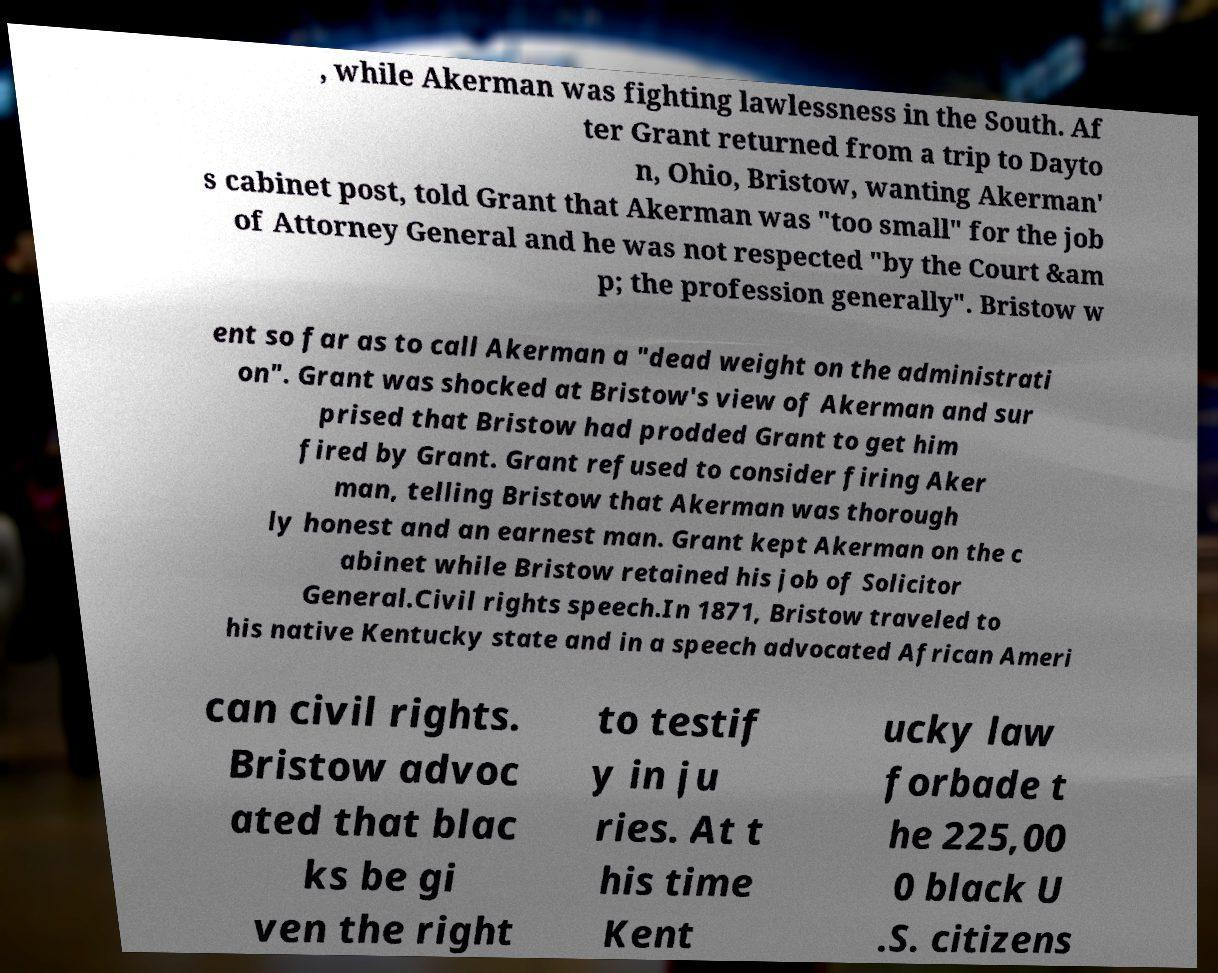There's text embedded in this image that I need extracted. Can you transcribe it verbatim? , while Akerman was fighting lawlessness in the South. Af ter Grant returned from a trip to Dayto n, Ohio, Bristow, wanting Akerman' s cabinet post, told Grant that Akerman was "too small" for the job of Attorney General and he was not respected "by the Court &am p; the profession generally". Bristow w ent so far as to call Akerman a "dead weight on the administrati on". Grant was shocked at Bristow's view of Akerman and sur prised that Bristow had prodded Grant to get him fired by Grant. Grant refused to consider firing Aker man, telling Bristow that Akerman was thorough ly honest and an earnest man. Grant kept Akerman on the c abinet while Bristow retained his job of Solicitor General.Civil rights speech.In 1871, Bristow traveled to his native Kentucky state and in a speech advocated African Ameri can civil rights. Bristow advoc ated that blac ks be gi ven the right to testif y in ju ries. At t his time Kent ucky law forbade t he 225,00 0 black U .S. citizens 